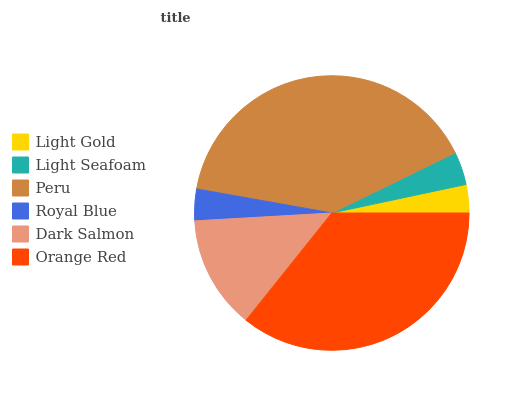Is Light Gold the minimum?
Answer yes or no. Yes. Is Peru the maximum?
Answer yes or no. Yes. Is Light Seafoam the minimum?
Answer yes or no. No. Is Light Seafoam the maximum?
Answer yes or no. No. Is Light Seafoam greater than Light Gold?
Answer yes or no. Yes. Is Light Gold less than Light Seafoam?
Answer yes or no. Yes. Is Light Gold greater than Light Seafoam?
Answer yes or no. No. Is Light Seafoam less than Light Gold?
Answer yes or no. No. Is Dark Salmon the high median?
Answer yes or no. Yes. Is Light Seafoam the low median?
Answer yes or no. Yes. Is Royal Blue the high median?
Answer yes or no. No. Is Royal Blue the low median?
Answer yes or no. No. 